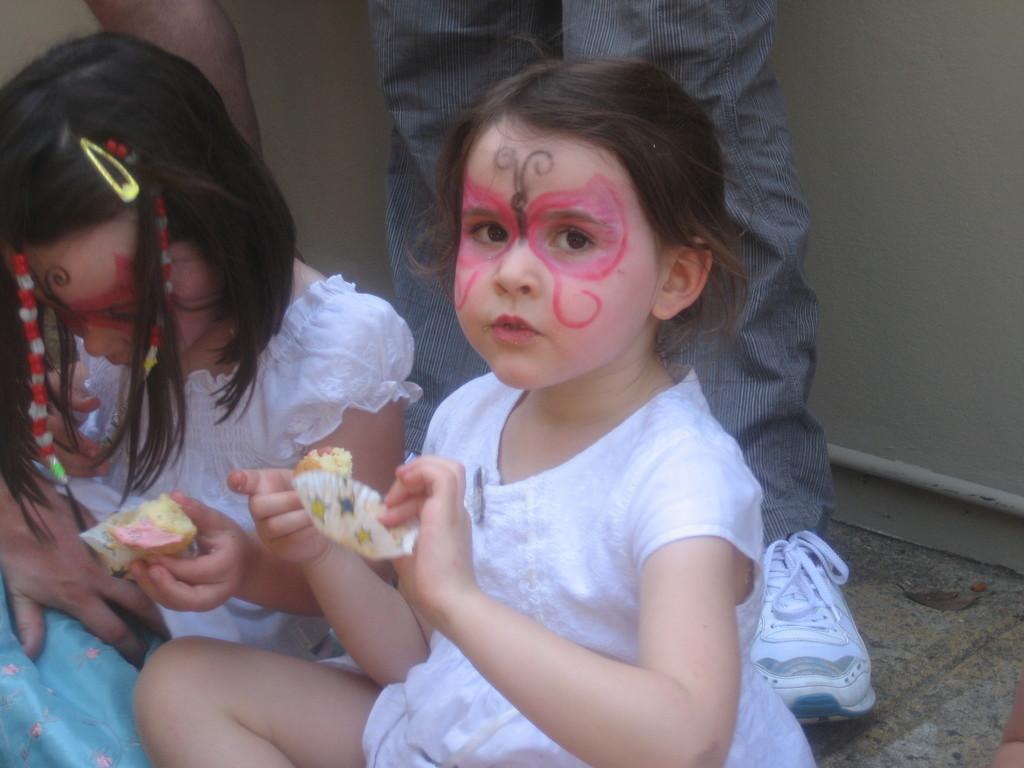How would you summarize this image in a sentence or two? In the image we can see two girls sitting, wearing clothes and they are holding a food item in their hand. Here we can see a person standing, wearing clothes and shoes. This is a floor. 